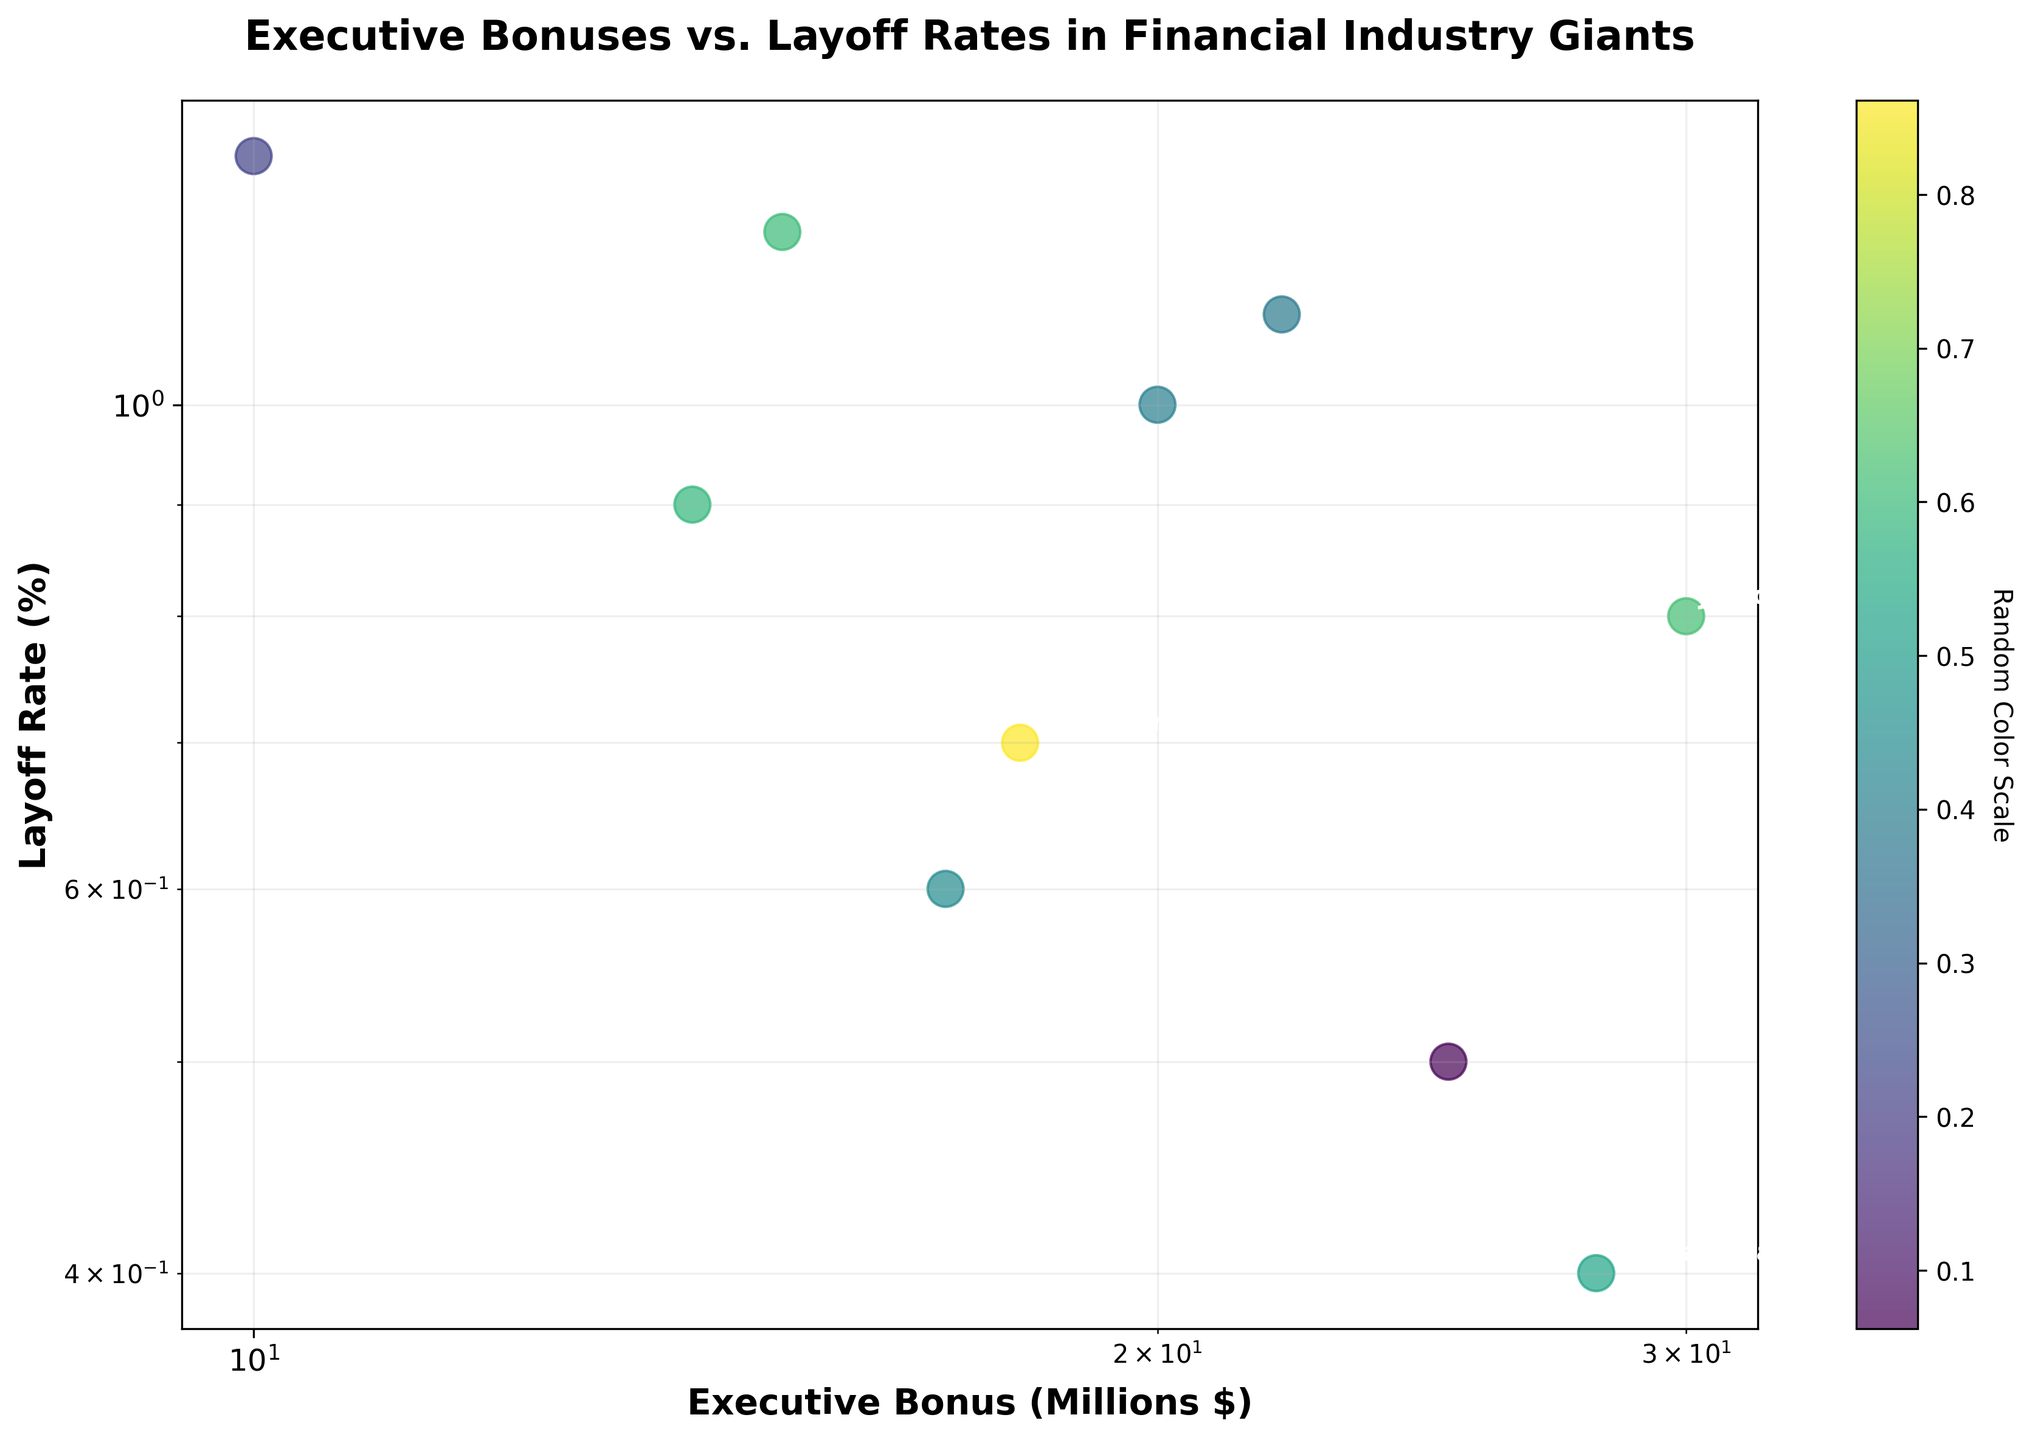What's the title of the figure? The title of the figure is usually displayed prominently on top of the chart. In this figure, the title is "Executive Bonuses vs. Layoff Rates in Financial Industry Giants".
Answer: Executive Bonuses vs. Layoff Rates in Financial Industry Giants What are the axes labels in the figure? The axes labels can be found next to the x-axis and y-axis. In this figure, the x-axis label is "Executive Bonus (Millions $)" and the y-axis label is "Layoff Rate (%)".
Answer: Executive Bonus (Millions $), Layoff Rate (%) How many data points are illustrated in the figure? By counting the number of scatter points in the figure, one can determine the number of data points. Since the data lists ten companies, there are ten data points in the figure.
Answer: 10 Which company has the highest layoff rate? The layoff rate is plotted on the y-axis. The highest point on the y-axis represents the highest layoff rate. According to the data, HSBC has the highest layoff rate of 1.3%.
Answer: HSBC Which company has the highest executive bonus? The executive bonus is plotted on the x-axis. The furthest point to the right on the x-axis represents the highest executive bonus. According to the data, JPMorgan Chase has the highest executive bonus of $30 million.
Answer: JPMorgan Chase What is the range of executive bonuses represented in the figure? To determine the range, identify the maximum and minimum values on the x-axis. The data indicates an executive bonus range from $10 million (HSBC) to $30 million (JPMorgan Chase).
Answer: $10 million to $30 million Is there any observable trend between executive bonuses and layoff rates? Observing the scatter plot, one can visually assess any patterns. There does not seem to be a clear, consistent relationship between executive bonuses and layoff rates, as points are scattered without a definitive trend.
Answer: No clear trend Which company has a similar layoff rate but a lower executive bonus compared to Morgan Stanley? First, find Morgan Stanley's layoff rate (0.4%) and then look for any other company with a similar layoff rate but a smaller executive bonus. UBS has a layoff rate of 0.6% which is close, but with a lower bonus of $17 million. Though the exact requirement isn't matched perfectly, UBS is the closest.
Answer: UBS What is the average layoff rate in the figure? Calculate the average by summing all layoff rates and dividing by the number of companies. (0.5 + 0.8 + 1.0 + 1.2 + 0.4 + 0.7 + 1.1 + 0.9 + 0.6 + 1.3) / 10 = 8.5 / 10 = 0.85%
Answer: 0.85% 